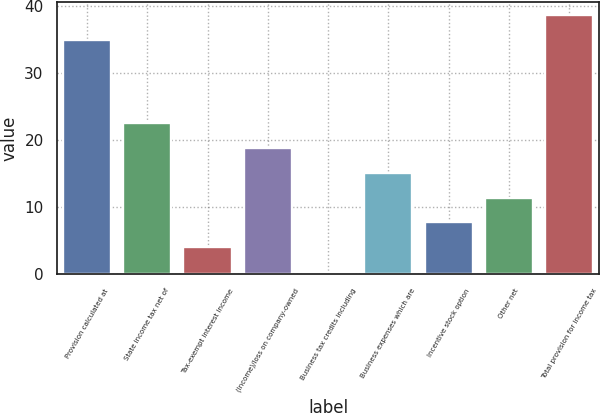Convert chart to OTSL. <chart><loc_0><loc_0><loc_500><loc_500><bar_chart><fcel>Provision calculated at<fcel>State income tax net of<fcel>Tax-exempt interest income<fcel>(Income)/loss on company-owned<fcel>Business tax credits including<fcel>Business expenses which are<fcel>Incentive stock option<fcel>Other net<fcel>Total provision for income tax<nl><fcel>35<fcel>22.54<fcel>4.09<fcel>18.85<fcel>0.4<fcel>15.16<fcel>7.78<fcel>11.47<fcel>38.69<nl></chart> 